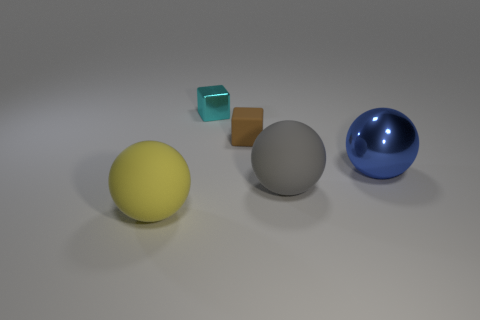Is the number of small cyan shiny cubes that are behind the blue ball greater than the number of small cyan shiny cylinders?
Offer a terse response. Yes. There is a tiny brown rubber object; is it the same shape as the big rubber thing left of the tiny cyan block?
Offer a very short reply. No. Are any yellow objects visible?
Give a very brief answer. Yes. What number of small things are matte balls or brown blocks?
Ensure brevity in your answer.  1. Is the number of blue spheres that are on the left side of the large gray matte thing greater than the number of big balls that are right of the large blue sphere?
Your response must be concise. No. Is the material of the large gray object the same as the big object left of the large gray rubber thing?
Your answer should be very brief. Yes. The tiny metallic cube has what color?
Provide a succinct answer. Cyan. There is a big gray matte object in front of the cyan metallic block; what is its shape?
Provide a short and direct response. Sphere. How many yellow things are big shiny things or tiny metallic blocks?
Provide a short and direct response. 0. The other sphere that is made of the same material as the gray sphere is what color?
Ensure brevity in your answer.  Yellow. 